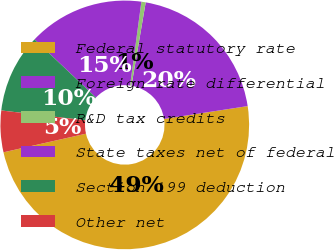Convert chart. <chart><loc_0><loc_0><loc_500><loc_500><pie_chart><fcel>Federal statutory rate<fcel>Foreign rate differential<fcel>R&D tax credits<fcel>State taxes net of federal<fcel>Section 199 deduction<fcel>Other net<nl><fcel>48.88%<fcel>19.89%<fcel>0.56%<fcel>15.06%<fcel>10.22%<fcel>5.39%<nl></chart> 